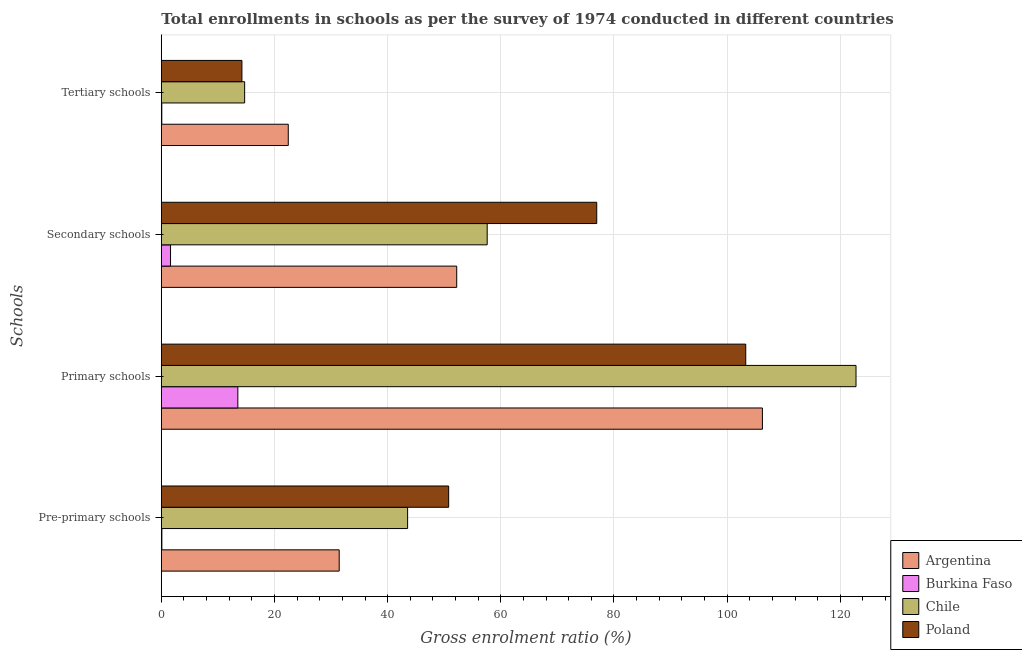How many bars are there on the 1st tick from the top?
Provide a succinct answer. 4. What is the label of the 3rd group of bars from the top?
Make the answer very short. Primary schools. What is the gross enrolment ratio in primary schools in Poland?
Your response must be concise. 103.29. Across all countries, what is the maximum gross enrolment ratio in tertiary schools?
Your answer should be very brief. 22.44. Across all countries, what is the minimum gross enrolment ratio in tertiary schools?
Keep it short and to the point. 0.09. In which country was the gross enrolment ratio in pre-primary schools maximum?
Your answer should be compact. Poland. In which country was the gross enrolment ratio in secondary schools minimum?
Your response must be concise. Burkina Faso. What is the total gross enrolment ratio in primary schools in the graph?
Offer a very short reply. 345.85. What is the difference between the gross enrolment ratio in primary schools in Burkina Faso and that in Chile?
Provide a short and direct response. -109.26. What is the difference between the gross enrolment ratio in pre-primary schools in Burkina Faso and the gross enrolment ratio in secondary schools in Poland?
Provide a succinct answer. -76.86. What is the average gross enrolment ratio in pre-primary schools per country?
Provide a short and direct response. 31.46. What is the difference between the gross enrolment ratio in secondary schools and gross enrolment ratio in tertiary schools in Poland?
Your answer should be very brief. 62.71. In how many countries, is the gross enrolment ratio in tertiary schools greater than 32 %?
Your response must be concise. 0. What is the ratio of the gross enrolment ratio in pre-primary schools in Poland to that in Burkina Faso?
Your answer should be very brief. 518.18. What is the difference between the highest and the second highest gross enrolment ratio in tertiary schools?
Offer a very short reply. 7.71. What is the difference between the highest and the lowest gross enrolment ratio in tertiary schools?
Offer a very short reply. 22.35. What does the 3rd bar from the top in Tertiary schools represents?
Ensure brevity in your answer.  Burkina Faso. What does the 2nd bar from the bottom in Secondary schools represents?
Your response must be concise. Burkina Faso. Is it the case that in every country, the sum of the gross enrolment ratio in pre-primary schools and gross enrolment ratio in primary schools is greater than the gross enrolment ratio in secondary schools?
Offer a terse response. Yes. What is the difference between two consecutive major ticks on the X-axis?
Provide a short and direct response. 20. Are the values on the major ticks of X-axis written in scientific E-notation?
Offer a terse response. No. Where does the legend appear in the graph?
Give a very brief answer. Bottom right. How are the legend labels stacked?
Offer a very short reply. Vertical. What is the title of the graph?
Provide a short and direct response. Total enrollments in schools as per the survey of 1974 conducted in different countries. What is the label or title of the X-axis?
Provide a succinct answer. Gross enrolment ratio (%). What is the label or title of the Y-axis?
Your response must be concise. Schools. What is the Gross enrolment ratio (%) in Argentina in Pre-primary schools?
Offer a very short reply. 31.44. What is the Gross enrolment ratio (%) of Burkina Faso in Pre-primary schools?
Make the answer very short. 0.1. What is the Gross enrolment ratio (%) of Chile in Pre-primary schools?
Ensure brevity in your answer.  43.53. What is the Gross enrolment ratio (%) in Poland in Pre-primary schools?
Offer a terse response. 50.79. What is the Gross enrolment ratio (%) in Argentina in Primary schools?
Offer a very short reply. 106.24. What is the Gross enrolment ratio (%) in Burkina Faso in Primary schools?
Offer a very short reply. 13.53. What is the Gross enrolment ratio (%) of Chile in Primary schools?
Give a very brief answer. 122.79. What is the Gross enrolment ratio (%) of Poland in Primary schools?
Your answer should be compact. 103.29. What is the Gross enrolment ratio (%) in Argentina in Secondary schools?
Provide a succinct answer. 52.21. What is the Gross enrolment ratio (%) of Burkina Faso in Secondary schools?
Ensure brevity in your answer.  1.63. What is the Gross enrolment ratio (%) in Chile in Secondary schools?
Offer a very short reply. 57.6. What is the Gross enrolment ratio (%) in Poland in Secondary schools?
Your answer should be very brief. 76.96. What is the Gross enrolment ratio (%) of Argentina in Tertiary schools?
Ensure brevity in your answer.  22.44. What is the Gross enrolment ratio (%) of Burkina Faso in Tertiary schools?
Your response must be concise. 0.09. What is the Gross enrolment ratio (%) of Chile in Tertiary schools?
Make the answer very short. 14.73. What is the Gross enrolment ratio (%) of Poland in Tertiary schools?
Your response must be concise. 14.25. Across all Schools, what is the maximum Gross enrolment ratio (%) of Argentina?
Make the answer very short. 106.24. Across all Schools, what is the maximum Gross enrolment ratio (%) of Burkina Faso?
Offer a very short reply. 13.53. Across all Schools, what is the maximum Gross enrolment ratio (%) of Chile?
Your answer should be very brief. 122.79. Across all Schools, what is the maximum Gross enrolment ratio (%) of Poland?
Give a very brief answer. 103.29. Across all Schools, what is the minimum Gross enrolment ratio (%) of Argentina?
Keep it short and to the point. 22.44. Across all Schools, what is the minimum Gross enrolment ratio (%) of Burkina Faso?
Offer a very short reply. 0.09. Across all Schools, what is the minimum Gross enrolment ratio (%) in Chile?
Your answer should be compact. 14.73. Across all Schools, what is the minimum Gross enrolment ratio (%) in Poland?
Give a very brief answer. 14.25. What is the total Gross enrolment ratio (%) of Argentina in the graph?
Keep it short and to the point. 212.33. What is the total Gross enrolment ratio (%) of Burkina Faso in the graph?
Your response must be concise. 15.34. What is the total Gross enrolment ratio (%) of Chile in the graph?
Your response must be concise. 238.64. What is the total Gross enrolment ratio (%) in Poland in the graph?
Ensure brevity in your answer.  245.28. What is the difference between the Gross enrolment ratio (%) of Argentina in Pre-primary schools and that in Primary schools?
Provide a succinct answer. -74.8. What is the difference between the Gross enrolment ratio (%) of Burkina Faso in Pre-primary schools and that in Primary schools?
Keep it short and to the point. -13.43. What is the difference between the Gross enrolment ratio (%) of Chile in Pre-primary schools and that in Primary schools?
Give a very brief answer. -79.25. What is the difference between the Gross enrolment ratio (%) of Poland in Pre-primary schools and that in Primary schools?
Offer a very short reply. -52.51. What is the difference between the Gross enrolment ratio (%) in Argentina in Pre-primary schools and that in Secondary schools?
Offer a terse response. -20.77. What is the difference between the Gross enrolment ratio (%) in Burkina Faso in Pre-primary schools and that in Secondary schools?
Provide a succinct answer. -1.53. What is the difference between the Gross enrolment ratio (%) in Chile in Pre-primary schools and that in Secondary schools?
Offer a very short reply. -14.06. What is the difference between the Gross enrolment ratio (%) in Poland in Pre-primary schools and that in Secondary schools?
Offer a very short reply. -26.17. What is the difference between the Gross enrolment ratio (%) in Argentina in Pre-primary schools and that in Tertiary schools?
Keep it short and to the point. 9. What is the difference between the Gross enrolment ratio (%) in Burkina Faso in Pre-primary schools and that in Tertiary schools?
Your answer should be very brief. 0.01. What is the difference between the Gross enrolment ratio (%) of Chile in Pre-primary schools and that in Tertiary schools?
Ensure brevity in your answer.  28.8. What is the difference between the Gross enrolment ratio (%) in Poland in Pre-primary schools and that in Tertiary schools?
Offer a very short reply. 36.54. What is the difference between the Gross enrolment ratio (%) in Argentina in Primary schools and that in Secondary schools?
Offer a very short reply. 54.03. What is the difference between the Gross enrolment ratio (%) of Burkina Faso in Primary schools and that in Secondary schools?
Offer a very short reply. 11.9. What is the difference between the Gross enrolment ratio (%) of Chile in Primary schools and that in Secondary schools?
Provide a succinct answer. 65.19. What is the difference between the Gross enrolment ratio (%) of Poland in Primary schools and that in Secondary schools?
Offer a terse response. 26.34. What is the difference between the Gross enrolment ratio (%) of Argentina in Primary schools and that in Tertiary schools?
Your answer should be very brief. 83.8. What is the difference between the Gross enrolment ratio (%) of Burkina Faso in Primary schools and that in Tertiary schools?
Keep it short and to the point. 13.44. What is the difference between the Gross enrolment ratio (%) in Chile in Primary schools and that in Tertiary schools?
Make the answer very short. 108.06. What is the difference between the Gross enrolment ratio (%) of Poland in Primary schools and that in Tertiary schools?
Offer a terse response. 89.05. What is the difference between the Gross enrolment ratio (%) of Argentina in Secondary schools and that in Tertiary schools?
Keep it short and to the point. 29.77. What is the difference between the Gross enrolment ratio (%) in Burkina Faso in Secondary schools and that in Tertiary schools?
Make the answer very short. 1.54. What is the difference between the Gross enrolment ratio (%) of Chile in Secondary schools and that in Tertiary schools?
Keep it short and to the point. 42.87. What is the difference between the Gross enrolment ratio (%) in Poland in Secondary schools and that in Tertiary schools?
Keep it short and to the point. 62.71. What is the difference between the Gross enrolment ratio (%) of Argentina in Pre-primary schools and the Gross enrolment ratio (%) of Burkina Faso in Primary schools?
Your response must be concise. 17.91. What is the difference between the Gross enrolment ratio (%) of Argentina in Pre-primary schools and the Gross enrolment ratio (%) of Chile in Primary schools?
Provide a succinct answer. -91.34. What is the difference between the Gross enrolment ratio (%) in Argentina in Pre-primary schools and the Gross enrolment ratio (%) in Poland in Primary schools?
Offer a terse response. -71.85. What is the difference between the Gross enrolment ratio (%) of Burkina Faso in Pre-primary schools and the Gross enrolment ratio (%) of Chile in Primary schools?
Your answer should be compact. -122.69. What is the difference between the Gross enrolment ratio (%) in Burkina Faso in Pre-primary schools and the Gross enrolment ratio (%) in Poland in Primary schools?
Give a very brief answer. -103.2. What is the difference between the Gross enrolment ratio (%) in Chile in Pre-primary schools and the Gross enrolment ratio (%) in Poland in Primary schools?
Your answer should be compact. -59.76. What is the difference between the Gross enrolment ratio (%) of Argentina in Pre-primary schools and the Gross enrolment ratio (%) of Burkina Faso in Secondary schools?
Your answer should be very brief. 29.81. What is the difference between the Gross enrolment ratio (%) of Argentina in Pre-primary schools and the Gross enrolment ratio (%) of Chile in Secondary schools?
Your response must be concise. -26.15. What is the difference between the Gross enrolment ratio (%) of Argentina in Pre-primary schools and the Gross enrolment ratio (%) of Poland in Secondary schools?
Make the answer very short. -45.52. What is the difference between the Gross enrolment ratio (%) of Burkina Faso in Pre-primary schools and the Gross enrolment ratio (%) of Chile in Secondary schools?
Your response must be concise. -57.5. What is the difference between the Gross enrolment ratio (%) of Burkina Faso in Pre-primary schools and the Gross enrolment ratio (%) of Poland in Secondary schools?
Keep it short and to the point. -76.86. What is the difference between the Gross enrolment ratio (%) in Chile in Pre-primary schools and the Gross enrolment ratio (%) in Poland in Secondary schools?
Your response must be concise. -33.43. What is the difference between the Gross enrolment ratio (%) in Argentina in Pre-primary schools and the Gross enrolment ratio (%) in Burkina Faso in Tertiary schools?
Offer a very short reply. 31.36. What is the difference between the Gross enrolment ratio (%) of Argentina in Pre-primary schools and the Gross enrolment ratio (%) of Chile in Tertiary schools?
Keep it short and to the point. 16.71. What is the difference between the Gross enrolment ratio (%) in Argentina in Pre-primary schools and the Gross enrolment ratio (%) in Poland in Tertiary schools?
Your answer should be very brief. 17.2. What is the difference between the Gross enrolment ratio (%) of Burkina Faso in Pre-primary schools and the Gross enrolment ratio (%) of Chile in Tertiary schools?
Ensure brevity in your answer.  -14.63. What is the difference between the Gross enrolment ratio (%) in Burkina Faso in Pre-primary schools and the Gross enrolment ratio (%) in Poland in Tertiary schools?
Offer a very short reply. -14.15. What is the difference between the Gross enrolment ratio (%) of Chile in Pre-primary schools and the Gross enrolment ratio (%) of Poland in Tertiary schools?
Keep it short and to the point. 29.29. What is the difference between the Gross enrolment ratio (%) in Argentina in Primary schools and the Gross enrolment ratio (%) in Burkina Faso in Secondary schools?
Provide a short and direct response. 104.61. What is the difference between the Gross enrolment ratio (%) of Argentina in Primary schools and the Gross enrolment ratio (%) of Chile in Secondary schools?
Keep it short and to the point. 48.65. What is the difference between the Gross enrolment ratio (%) in Argentina in Primary schools and the Gross enrolment ratio (%) in Poland in Secondary schools?
Offer a terse response. 29.29. What is the difference between the Gross enrolment ratio (%) of Burkina Faso in Primary schools and the Gross enrolment ratio (%) of Chile in Secondary schools?
Give a very brief answer. -44.07. What is the difference between the Gross enrolment ratio (%) in Burkina Faso in Primary schools and the Gross enrolment ratio (%) in Poland in Secondary schools?
Offer a terse response. -63.43. What is the difference between the Gross enrolment ratio (%) in Chile in Primary schools and the Gross enrolment ratio (%) in Poland in Secondary schools?
Make the answer very short. 45.83. What is the difference between the Gross enrolment ratio (%) of Argentina in Primary schools and the Gross enrolment ratio (%) of Burkina Faso in Tertiary schools?
Your answer should be compact. 106.16. What is the difference between the Gross enrolment ratio (%) of Argentina in Primary schools and the Gross enrolment ratio (%) of Chile in Tertiary schools?
Offer a very short reply. 91.51. What is the difference between the Gross enrolment ratio (%) of Argentina in Primary schools and the Gross enrolment ratio (%) of Poland in Tertiary schools?
Offer a terse response. 92. What is the difference between the Gross enrolment ratio (%) in Burkina Faso in Primary schools and the Gross enrolment ratio (%) in Chile in Tertiary schools?
Offer a very short reply. -1.2. What is the difference between the Gross enrolment ratio (%) of Burkina Faso in Primary schools and the Gross enrolment ratio (%) of Poland in Tertiary schools?
Make the answer very short. -0.72. What is the difference between the Gross enrolment ratio (%) in Chile in Primary schools and the Gross enrolment ratio (%) in Poland in Tertiary schools?
Offer a terse response. 108.54. What is the difference between the Gross enrolment ratio (%) of Argentina in Secondary schools and the Gross enrolment ratio (%) of Burkina Faso in Tertiary schools?
Your response must be concise. 52.13. What is the difference between the Gross enrolment ratio (%) in Argentina in Secondary schools and the Gross enrolment ratio (%) in Chile in Tertiary schools?
Provide a short and direct response. 37.48. What is the difference between the Gross enrolment ratio (%) of Argentina in Secondary schools and the Gross enrolment ratio (%) of Poland in Tertiary schools?
Provide a succinct answer. 37.97. What is the difference between the Gross enrolment ratio (%) of Burkina Faso in Secondary schools and the Gross enrolment ratio (%) of Chile in Tertiary schools?
Your response must be concise. -13.1. What is the difference between the Gross enrolment ratio (%) of Burkina Faso in Secondary schools and the Gross enrolment ratio (%) of Poland in Tertiary schools?
Your response must be concise. -12.62. What is the difference between the Gross enrolment ratio (%) in Chile in Secondary schools and the Gross enrolment ratio (%) in Poland in Tertiary schools?
Make the answer very short. 43.35. What is the average Gross enrolment ratio (%) in Argentina per Schools?
Your answer should be compact. 53.08. What is the average Gross enrolment ratio (%) of Burkina Faso per Schools?
Ensure brevity in your answer.  3.83. What is the average Gross enrolment ratio (%) of Chile per Schools?
Provide a succinct answer. 59.66. What is the average Gross enrolment ratio (%) of Poland per Schools?
Make the answer very short. 61.32. What is the difference between the Gross enrolment ratio (%) in Argentina and Gross enrolment ratio (%) in Burkina Faso in Pre-primary schools?
Make the answer very short. 31.34. What is the difference between the Gross enrolment ratio (%) in Argentina and Gross enrolment ratio (%) in Chile in Pre-primary schools?
Your answer should be very brief. -12.09. What is the difference between the Gross enrolment ratio (%) of Argentina and Gross enrolment ratio (%) of Poland in Pre-primary schools?
Your answer should be very brief. -19.35. What is the difference between the Gross enrolment ratio (%) of Burkina Faso and Gross enrolment ratio (%) of Chile in Pre-primary schools?
Provide a short and direct response. -43.43. What is the difference between the Gross enrolment ratio (%) in Burkina Faso and Gross enrolment ratio (%) in Poland in Pre-primary schools?
Offer a terse response. -50.69. What is the difference between the Gross enrolment ratio (%) of Chile and Gross enrolment ratio (%) of Poland in Pre-primary schools?
Give a very brief answer. -7.26. What is the difference between the Gross enrolment ratio (%) in Argentina and Gross enrolment ratio (%) in Burkina Faso in Primary schools?
Offer a very short reply. 92.72. What is the difference between the Gross enrolment ratio (%) of Argentina and Gross enrolment ratio (%) of Chile in Primary schools?
Provide a succinct answer. -16.54. What is the difference between the Gross enrolment ratio (%) of Argentina and Gross enrolment ratio (%) of Poland in Primary schools?
Your response must be concise. 2.95. What is the difference between the Gross enrolment ratio (%) in Burkina Faso and Gross enrolment ratio (%) in Chile in Primary schools?
Give a very brief answer. -109.26. What is the difference between the Gross enrolment ratio (%) of Burkina Faso and Gross enrolment ratio (%) of Poland in Primary schools?
Make the answer very short. -89.77. What is the difference between the Gross enrolment ratio (%) of Chile and Gross enrolment ratio (%) of Poland in Primary schools?
Your answer should be very brief. 19.49. What is the difference between the Gross enrolment ratio (%) of Argentina and Gross enrolment ratio (%) of Burkina Faso in Secondary schools?
Provide a succinct answer. 50.58. What is the difference between the Gross enrolment ratio (%) of Argentina and Gross enrolment ratio (%) of Chile in Secondary schools?
Provide a succinct answer. -5.38. What is the difference between the Gross enrolment ratio (%) of Argentina and Gross enrolment ratio (%) of Poland in Secondary schools?
Ensure brevity in your answer.  -24.75. What is the difference between the Gross enrolment ratio (%) of Burkina Faso and Gross enrolment ratio (%) of Chile in Secondary schools?
Provide a succinct answer. -55.97. What is the difference between the Gross enrolment ratio (%) of Burkina Faso and Gross enrolment ratio (%) of Poland in Secondary schools?
Give a very brief answer. -75.33. What is the difference between the Gross enrolment ratio (%) in Chile and Gross enrolment ratio (%) in Poland in Secondary schools?
Give a very brief answer. -19.36. What is the difference between the Gross enrolment ratio (%) in Argentina and Gross enrolment ratio (%) in Burkina Faso in Tertiary schools?
Your response must be concise. 22.35. What is the difference between the Gross enrolment ratio (%) of Argentina and Gross enrolment ratio (%) of Chile in Tertiary schools?
Offer a very short reply. 7.71. What is the difference between the Gross enrolment ratio (%) in Argentina and Gross enrolment ratio (%) in Poland in Tertiary schools?
Give a very brief answer. 8.19. What is the difference between the Gross enrolment ratio (%) in Burkina Faso and Gross enrolment ratio (%) in Chile in Tertiary schools?
Offer a very short reply. -14.64. What is the difference between the Gross enrolment ratio (%) of Burkina Faso and Gross enrolment ratio (%) of Poland in Tertiary schools?
Your response must be concise. -14.16. What is the difference between the Gross enrolment ratio (%) in Chile and Gross enrolment ratio (%) in Poland in Tertiary schools?
Your answer should be very brief. 0.48. What is the ratio of the Gross enrolment ratio (%) in Argentina in Pre-primary schools to that in Primary schools?
Ensure brevity in your answer.  0.3. What is the ratio of the Gross enrolment ratio (%) of Burkina Faso in Pre-primary schools to that in Primary schools?
Your response must be concise. 0.01. What is the ratio of the Gross enrolment ratio (%) of Chile in Pre-primary schools to that in Primary schools?
Provide a short and direct response. 0.35. What is the ratio of the Gross enrolment ratio (%) in Poland in Pre-primary schools to that in Primary schools?
Give a very brief answer. 0.49. What is the ratio of the Gross enrolment ratio (%) of Argentina in Pre-primary schools to that in Secondary schools?
Your answer should be compact. 0.6. What is the ratio of the Gross enrolment ratio (%) of Burkina Faso in Pre-primary schools to that in Secondary schools?
Provide a succinct answer. 0.06. What is the ratio of the Gross enrolment ratio (%) of Chile in Pre-primary schools to that in Secondary schools?
Make the answer very short. 0.76. What is the ratio of the Gross enrolment ratio (%) in Poland in Pre-primary schools to that in Secondary schools?
Provide a succinct answer. 0.66. What is the ratio of the Gross enrolment ratio (%) in Argentina in Pre-primary schools to that in Tertiary schools?
Make the answer very short. 1.4. What is the ratio of the Gross enrolment ratio (%) in Burkina Faso in Pre-primary schools to that in Tertiary schools?
Your response must be concise. 1.14. What is the ratio of the Gross enrolment ratio (%) in Chile in Pre-primary schools to that in Tertiary schools?
Keep it short and to the point. 2.96. What is the ratio of the Gross enrolment ratio (%) of Poland in Pre-primary schools to that in Tertiary schools?
Your answer should be very brief. 3.57. What is the ratio of the Gross enrolment ratio (%) in Argentina in Primary schools to that in Secondary schools?
Your answer should be very brief. 2.03. What is the ratio of the Gross enrolment ratio (%) in Burkina Faso in Primary schools to that in Secondary schools?
Your response must be concise. 8.31. What is the ratio of the Gross enrolment ratio (%) in Chile in Primary schools to that in Secondary schools?
Keep it short and to the point. 2.13. What is the ratio of the Gross enrolment ratio (%) of Poland in Primary schools to that in Secondary schools?
Give a very brief answer. 1.34. What is the ratio of the Gross enrolment ratio (%) of Argentina in Primary schools to that in Tertiary schools?
Offer a very short reply. 4.73. What is the ratio of the Gross enrolment ratio (%) of Burkina Faso in Primary schools to that in Tertiary schools?
Your answer should be very brief. 157.24. What is the ratio of the Gross enrolment ratio (%) of Chile in Primary schools to that in Tertiary schools?
Offer a very short reply. 8.34. What is the ratio of the Gross enrolment ratio (%) in Poland in Primary schools to that in Tertiary schools?
Give a very brief answer. 7.25. What is the ratio of the Gross enrolment ratio (%) in Argentina in Secondary schools to that in Tertiary schools?
Make the answer very short. 2.33. What is the ratio of the Gross enrolment ratio (%) in Burkina Faso in Secondary schools to that in Tertiary schools?
Provide a succinct answer. 18.93. What is the ratio of the Gross enrolment ratio (%) in Chile in Secondary schools to that in Tertiary schools?
Your answer should be compact. 3.91. What is the ratio of the Gross enrolment ratio (%) of Poland in Secondary schools to that in Tertiary schools?
Ensure brevity in your answer.  5.4. What is the difference between the highest and the second highest Gross enrolment ratio (%) of Argentina?
Give a very brief answer. 54.03. What is the difference between the highest and the second highest Gross enrolment ratio (%) in Burkina Faso?
Offer a very short reply. 11.9. What is the difference between the highest and the second highest Gross enrolment ratio (%) in Chile?
Your answer should be compact. 65.19. What is the difference between the highest and the second highest Gross enrolment ratio (%) in Poland?
Give a very brief answer. 26.34. What is the difference between the highest and the lowest Gross enrolment ratio (%) in Argentina?
Your answer should be very brief. 83.8. What is the difference between the highest and the lowest Gross enrolment ratio (%) of Burkina Faso?
Provide a succinct answer. 13.44. What is the difference between the highest and the lowest Gross enrolment ratio (%) in Chile?
Your answer should be compact. 108.06. What is the difference between the highest and the lowest Gross enrolment ratio (%) of Poland?
Give a very brief answer. 89.05. 